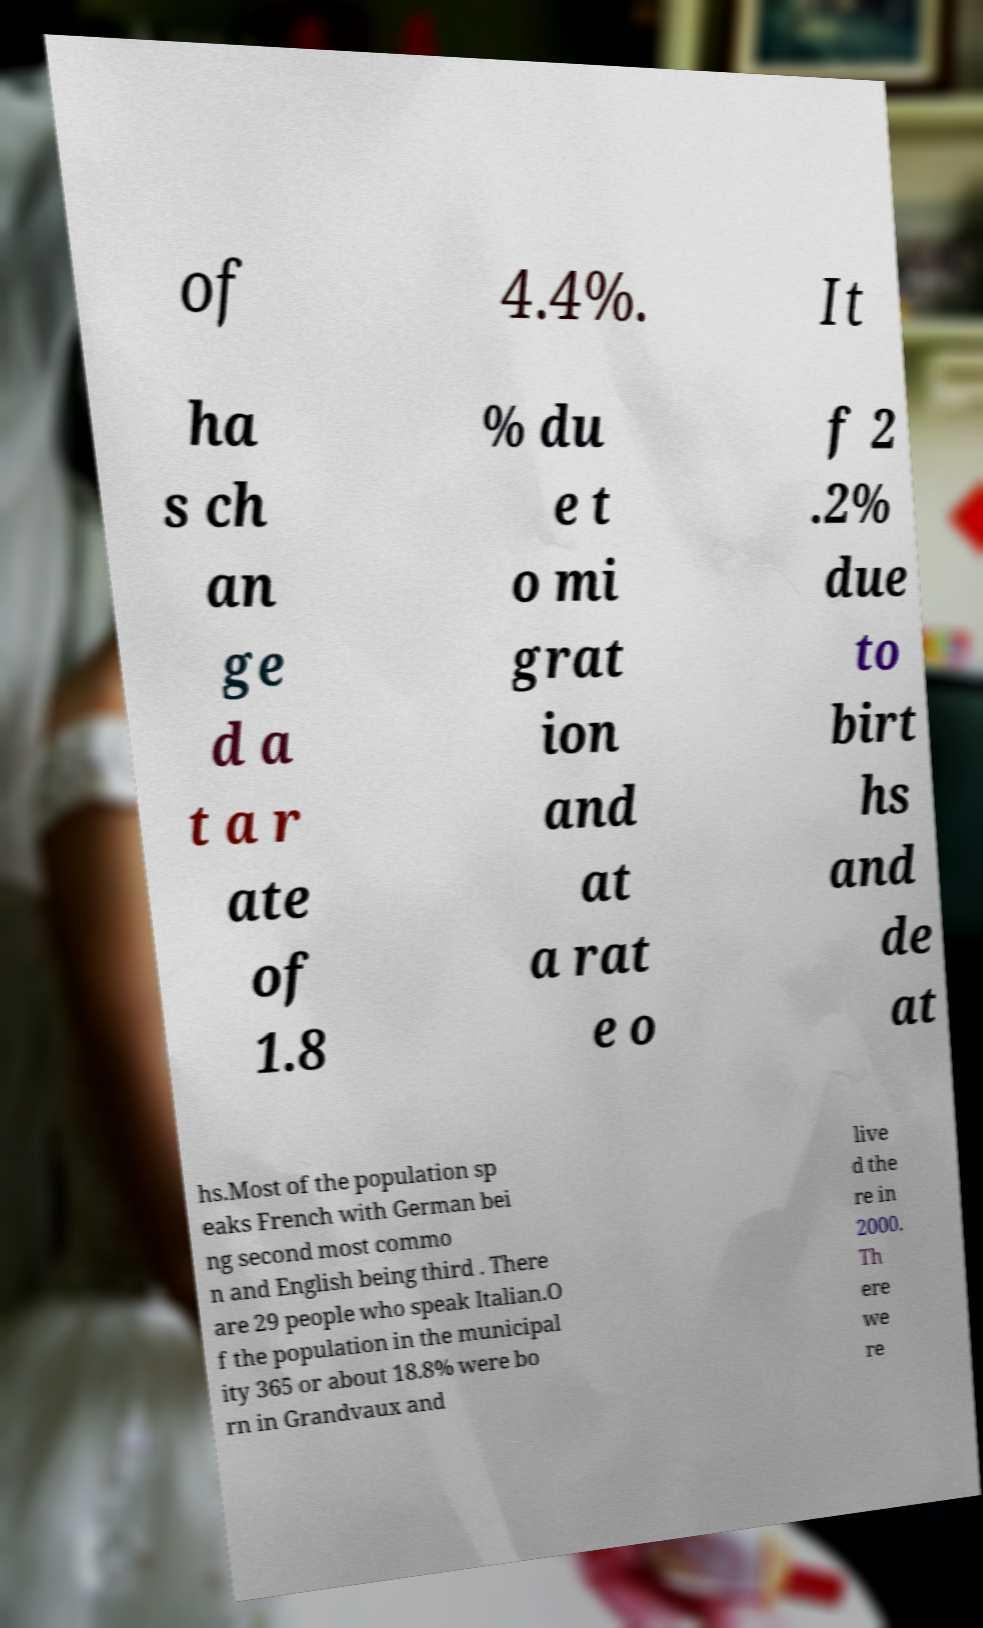I need the written content from this picture converted into text. Can you do that? of 4.4%. It ha s ch an ge d a t a r ate of 1.8 % du e t o mi grat ion and at a rat e o f 2 .2% due to birt hs and de at hs.Most of the population sp eaks French with German bei ng second most commo n and English being third . There are 29 people who speak Italian.O f the population in the municipal ity 365 or about 18.8% were bo rn in Grandvaux and live d the re in 2000. Th ere we re 